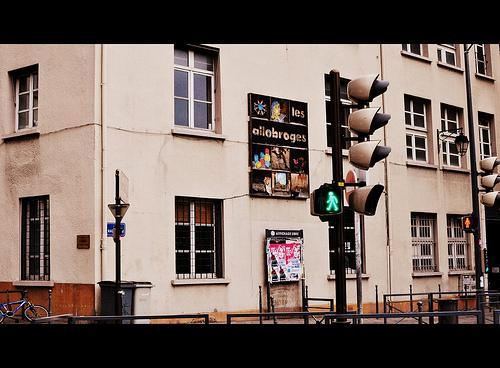Can you identify an object in the image which may have a creative or artistic aspect to it? There is a colorful sign on the side of a building that serves as a wonderful art display. State one object that serves a purpose for directing or informing pedestrians. A green pedestrian walk light is visible, which helps guide pedestrians when it's safe to walk. Provide a brief explanation of the object seen near the black metal bars. Caging can be seen over a set of windows near the black metal bars, providing added security for the building. Describe a scene of an interaction between two or more objects in the image. A blue bicycle is leaning against the wall of a building under a window, showing a connection between the bicycle, building, and window. What type of object can you see in the image that has a relation to transportation? A blue bicycle leaning against a wall of a building can be seen in the image, which is a mode of transportation. Perform a quantitative assessment of the image quality based on the clarity and sharpness of the objects. The image quality is moderate due to the clarity of some objects, but several objects are not very sharp. Determine the number of trash bins seen in the image and describe their appearance. There are two trash bins next to the building, one black and one white. In less than 10 words, express the general sentiment or mood conveyed by the image. Urban setting with various signs, lights, and a bicycle. Provide a short description of the lighting object seen in the image. An elegant street light is located in the image, characterized by its black color and attachment to a pole. Count the total number of traffic and pedestrian lights present in the image. There are a total of 8 traffic and pedestrian lights in the image. Notice the baby stroller left unattended on the corner, near the blue and white sign on the side of the corner building. No, it's not mentioned in the image. What emotion can you infer the most from the scene? Calm List the colors of the two trash bins located next to the building. Black and white Are there any ornamental black metal poles on the city sidewalk? Yes Provide a concise description of the building's window features. The building's windows have a white frame, brown blinds, and are covered by black metal bars. Explain the main event happening in the image. There isn't a distinct main event occurring in the image, it's a regular urban scene. Compose a brief narrative about the scene, emphasizing on the pedestrian light. Amidst the bustling cityscape, the green pedestrian light serves as a beacon, guiding passersby to safely traverse the urban labyrinth. Does the image depict a green pedestrian walk light or an orange caution walking light? Both green pedestrian walk light and orange caution walking light What color is the bicycle leaning against the rail? Blue Express the presence of a street light in a more poetic way. An elegant lantern casts its gentle glow upon the thoroughfare below. Among the following options, which describes the sign hanging on the side of the building? A) colorful sign B) gold and black plaque C) blue and white sign D) red and white poster A) colorful sign Does the building have brown blinds in the window or white frame on the window?   Both brown blinds and white frame Locate a pedestrian sign with a red symbol on the light pole. Red pedestrian sign on the light pole Identify the type of activity taking place near the blue bicycle. No specific activity is recognizable Is there any indication of a community event in the image? Yes, a community board of events Read the text on the colorful sign hanging on the side of the building. Cannot read the text from the given image Which type of diagram would best represent the spatial arrangement of objects in the image? A) flowchart B) Venn diagram C) mind map D) Sankey diagram C) mind map Write an event advertisement for the "wonderful art display" at the location shown in the image. Join us for a mesmerizing art exhibition, featuring the finest talents in town! Immerse yourself in vibrant colors and unique textures as you explore the magnificent works on display, located alongside city's bustling streets. Experience the confluence of art with urban life, transforming the corner building into a canvas of creativity! If you were to create a multimedia presentation about the image, which elements would be crucial to include? Blue bicycle, pedestrian lights, traffic lights, building windows, street light, and trash bins Rewrite the following statement in a more sophisticated language style: "A blue bicycle is leaning against a wall of a building." An azure velocipede reclines gracefully against the edifice's facade. Find the number of lights in the stop light with four lights and the stop light with three lights. Four lights in one stop light and three lights in the other stop light 